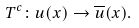Convert formula to latex. <formula><loc_0><loc_0><loc_500><loc_500>T ^ { c } \colon u ( x ) \rightarrow \overline { u } ( x ) .</formula> 